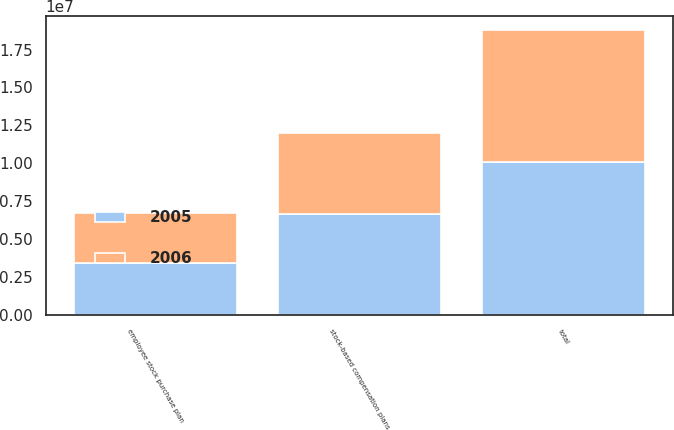Convert chart. <chart><loc_0><loc_0><loc_500><loc_500><stacked_bar_chart><ecel><fcel>employee stock purchase plan<fcel>stock-based compensation plans<fcel>total<nl><fcel>2006<fcel>3.34774e+06<fcel>5.31288e+06<fcel>8.66062e+06<nl><fcel>2005<fcel>3.41233e+06<fcel>6.69617e+06<fcel>1.01085e+07<nl></chart> 